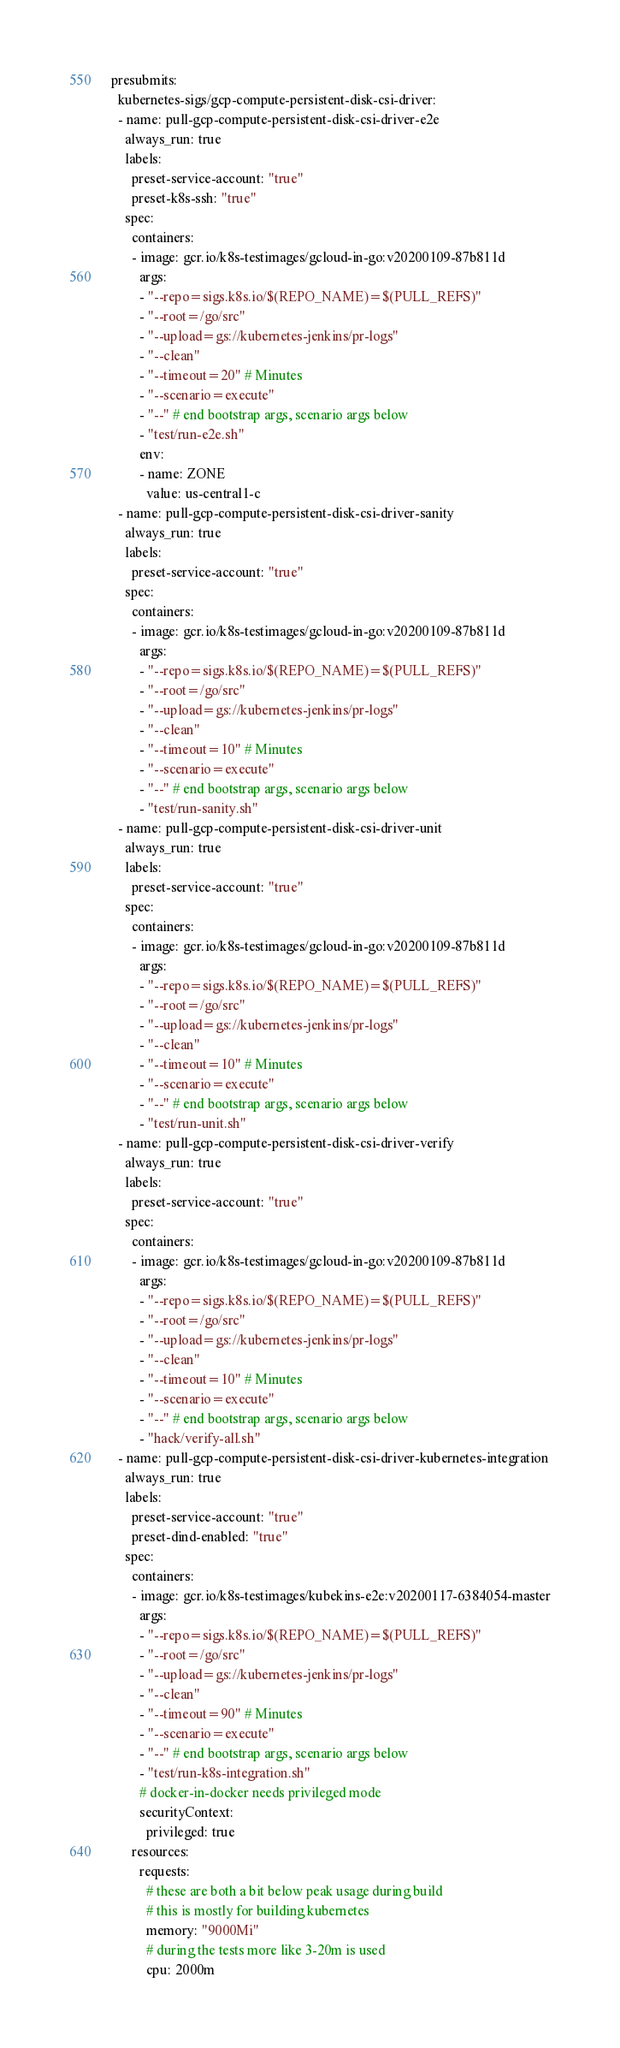<code> <loc_0><loc_0><loc_500><loc_500><_YAML_>presubmits:
  kubernetes-sigs/gcp-compute-persistent-disk-csi-driver:
  - name: pull-gcp-compute-persistent-disk-csi-driver-e2e
    always_run: true
    labels:
      preset-service-account: "true"
      preset-k8s-ssh: "true"
    spec:
      containers:
      - image: gcr.io/k8s-testimages/gcloud-in-go:v20200109-87b811d
        args:
        - "--repo=sigs.k8s.io/$(REPO_NAME)=$(PULL_REFS)"
        - "--root=/go/src"
        - "--upload=gs://kubernetes-jenkins/pr-logs"
        - "--clean"
        - "--timeout=20" # Minutes
        - "--scenario=execute"
        - "--" # end bootstrap args, scenario args below
        - "test/run-e2e.sh"
        env:
        - name: ZONE
          value: us-central1-c
  - name: pull-gcp-compute-persistent-disk-csi-driver-sanity
    always_run: true
    labels:
      preset-service-account: "true"
    spec:
      containers:
      - image: gcr.io/k8s-testimages/gcloud-in-go:v20200109-87b811d
        args:
        - "--repo=sigs.k8s.io/$(REPO_NAME)=$(PULL_REFS)"
        - "--root=/go/src"
        - "--upload=gs://kubernetes-jenkins/pr-logs"
        - "--clean"
        - "--timeout=10" # Minutes
        - "--scenario=execute"
        - "--" # end bootstrap args, scenario args below
        - "test/run-sanity.sh"
  - name: pull-gcp-compute-persistent-disk-csi-driver-unit
    always_run: true
    labels:
      preset-service-account: "true"
    spec:
      containers:
      - image: gcr.io/k8s-testimages/gcloud-in-go:v20200109-87b811d
        args:
        - "--repo=sigs.k8s.io/$(REPO_NAME)=$(PULL_REFS)"
        - "--root=/go/src"
        - "--upload=gs://kubernetes-jenkins/pr-logs"
        - "--clean"
        - "--timeout=10" # Minutes
        - "--scenario=execute"
        - "--" # end bootstrap args, scenario args below
        - "test/run-unit.sh"
  - name: pull-gcp-compute-persistent-disk-csi-driver-verify
    always_run: true
    labels:
      preset-service-account: "true"
    spec:
      containers:
      - image: gcr.io/k8s-testimages/gcloud-in-go:v20200109-87b811d
        args:
        - "--repo=sigs.k8s.io/$(REPO_NAME)=$(PULL_REFS)"
        - "--root=/go/src"
        - "--upload=gs://kubernetes-jenkins/pr-logs"
        - "--clean"
        - "--timeout=10" # Minutes
        - "--scenario=execute"
        - "--" # end bootstrap args, scenario args below
        - "hack/verify-all.sh"
  - name: pull-gcp-compute-persistent-disk-csi-driver-kubernetes-integration
    always_run: true
    labels:
      preset-service-account: "true"
      preset-dind-enabled: "true"
    spec:
      containers:
      - image: gcr.io/k8s-testimages/kubekins-e2e:v20200117-6384054-master
        args:
        - "--repo=sigs.k8s.io/$(REPO_NAME)=$(PULL_REFS)"
        - "--root=/go/src"
        - "--upload=gs://kubernetes-jenkins/pr-logs"
        - "--clean"
        - "--timeout=90" # Minutes
        - "--scenario=execute"
        - "--" # end bootstrap args, scenario args below
        - "test/run-k8s-integration.sh"
        # docker-in-docker needs privileged mode
        securityContext:
          privileged: true
      resources:
        requests:
          # these are both a bit below peak usage during build
          # this is mostly for building kubernetes
          memory: "9000Mi"
          # during the tests more like 3-20m is used
          cpu: 2000m
</code> 